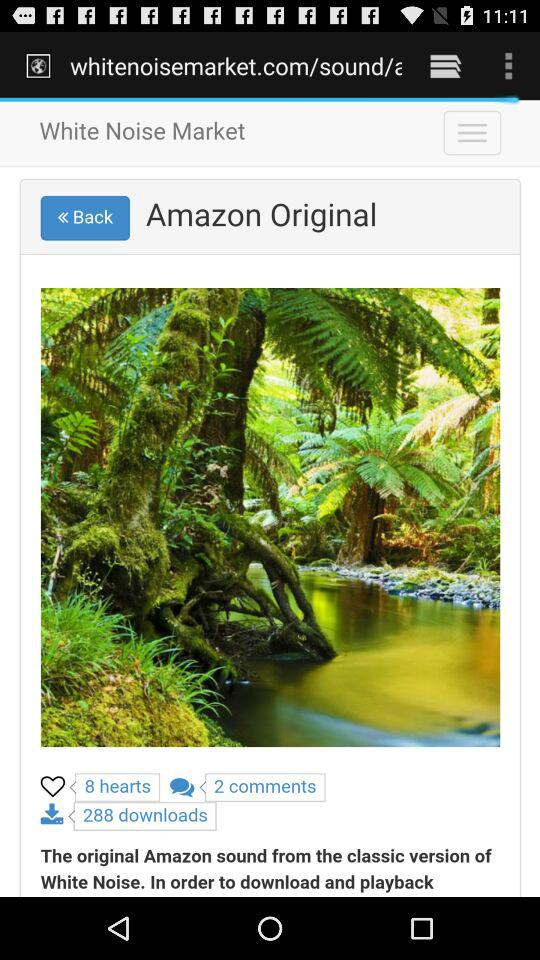How many downloads are there? There are 288 downloads. 